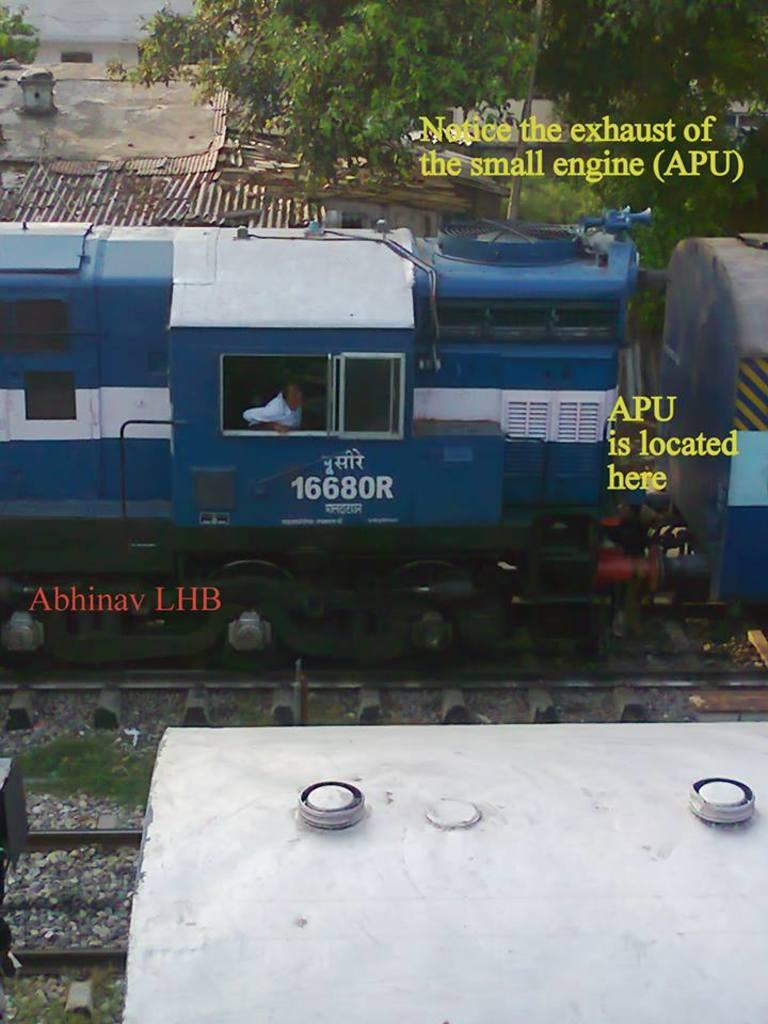What type of vehicle is in the image? There is a blue color train in the image. Where is the train located? The train is on a railway track. What can be seen in the background of the image? There are houses and trees in the background of the image. Is there any text present in the image? Yes, there is text written on the image. What type of leather material is used to make the club in the image? There is no club or leather material present in the image; it features a blue color train on a railway track. 